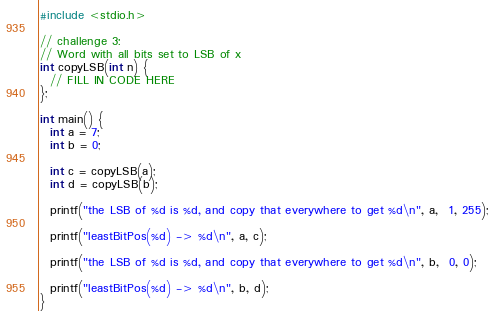Convert code to text. <code><loc_0><loc_0><loc_500><loc_500><_C_>#include <stdio.h>

// challenge 3:
// Word with all bits set to LSB of x
int copyLSB(int n) {
  // FILL IN CODE HERE
};

int main() {
  int a = 7;
  int b = 0;

  int c = copyLSB(a);
  int d = copyLSB(b);

  printf("the LSB of %d is %d, and copy that everywhere to get %d\n", a,  1, 255);

  printf("leastBitPos(%d) -> %d\n", a, c);

  printf("the LSB of %d is %d, and copy that everywhere to get %d\n", b,  0, 0);

  printf("leastBitPos(%d) -> %d\n", b, d);
}
</code> 